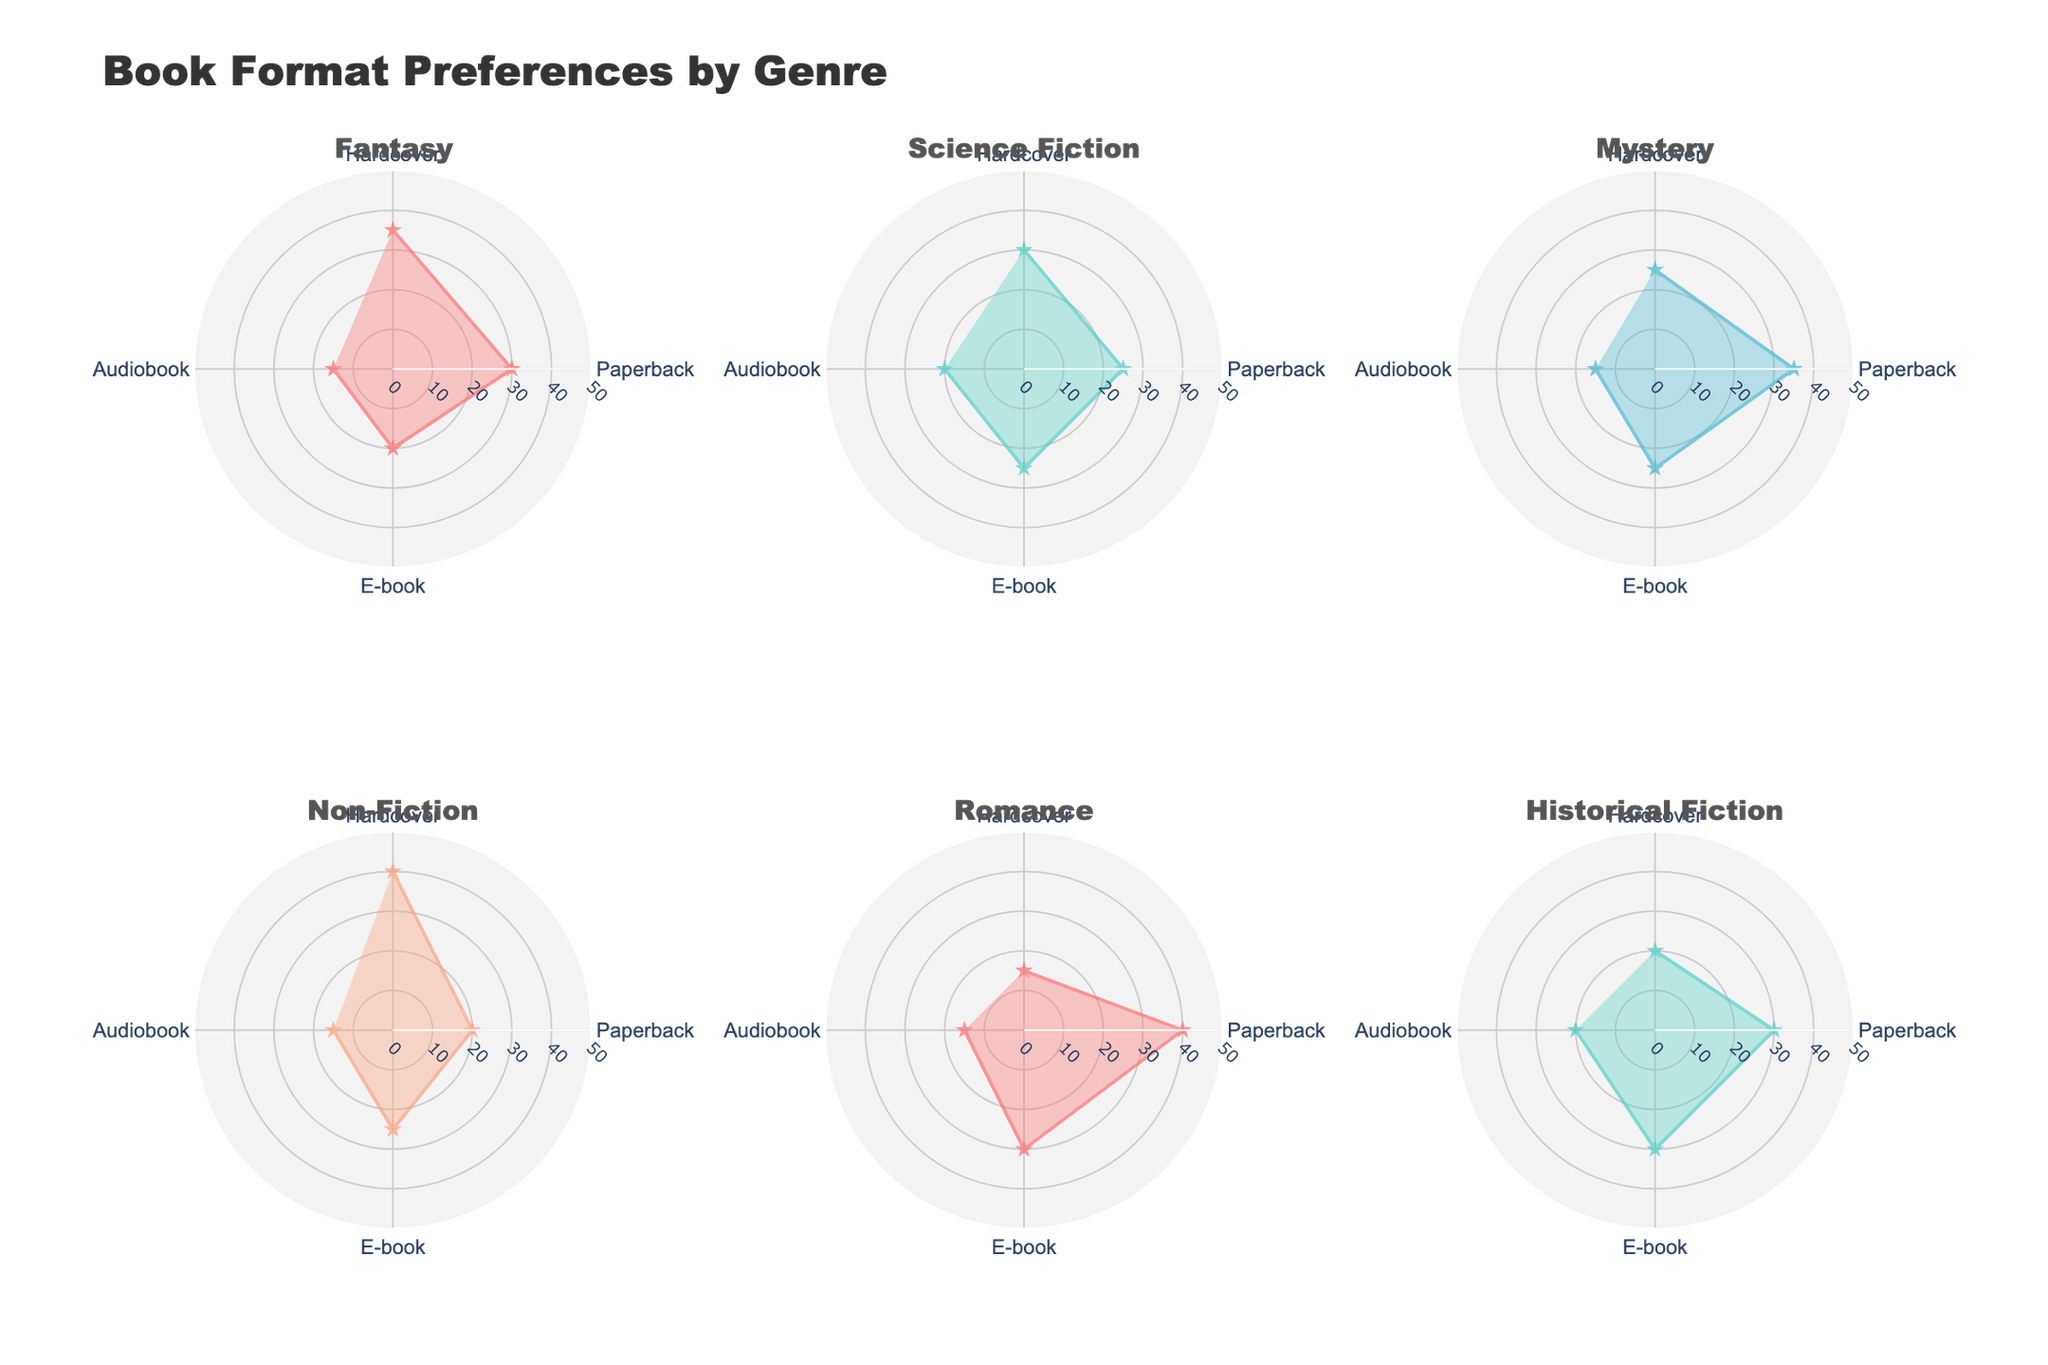Which genre has the highest preference for paperbacks? By looking at the radar chart, among the different genres, Romance has the highest percentage for paperbacks with 40%.
Answer: Romance Which genre has the lowest preference for audiobooks? On the radar chart, Fantasy, Mystery, Non-Fiction, Romance, and Historical Fiction all have the same lowest preference for audiobooks at 15%.
Answer: Fantasy, Mystery, Non-Fiction, Romance, Historical Fiction What is the total percentage preference for e-books across all genres? Summing up the e-book preferences from each genre: Fantasy (20) + Science Fiction (25) + Mystery (25) + Non-Fiction (25) + Romance (30) + Historical Fiction (30) = 155%
Answer: 155% Which genres have a higher preference for hardcovers compared to paperbacks? Comparing the values for each genre, Fantasy (35% vs 30%), Non-Fiction (40% vs 20%) have higher preferences for hardcovers compared to paperbacks.
Answer: Fantasy, Non-Fiction What is the difference in preference for paperbacks between Romance and Mystery? The percentage preference for paperbacks in Romance is 40% and in Mystery is 35%. The difference is 40 - 35 = 5%.
Answer: 5% What is the average preference for audiobooks across all genres? The preferences for audiobooks are: Fantasy (15), Science Fiction (20), Mystery (15), Non-Fiction (15), Romance (15), Historical Fiction (20). The average is (15+20+15+15+15+20)/6 = 16.67%.
Answer: 16.67% Which genre has the most balanced preference distribution among the four formats? Looking at the radar charts, Historical Fiction has the most balanced distribution with preferences of 20% (Hardcover), 30% (Paperback), 30% (E-book), and 20% (Audiobook).
Answer: Historical Fiction Which format is least preferred in Science Fiction? From the radar chart for Science Fiction, both Paperback and E-book have the lowest preferences (25%).
Answer: Paperback, E-book 